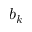<formula> <loc_0><loc_0><loc_500><loc_500>b _ { k }</formula> 